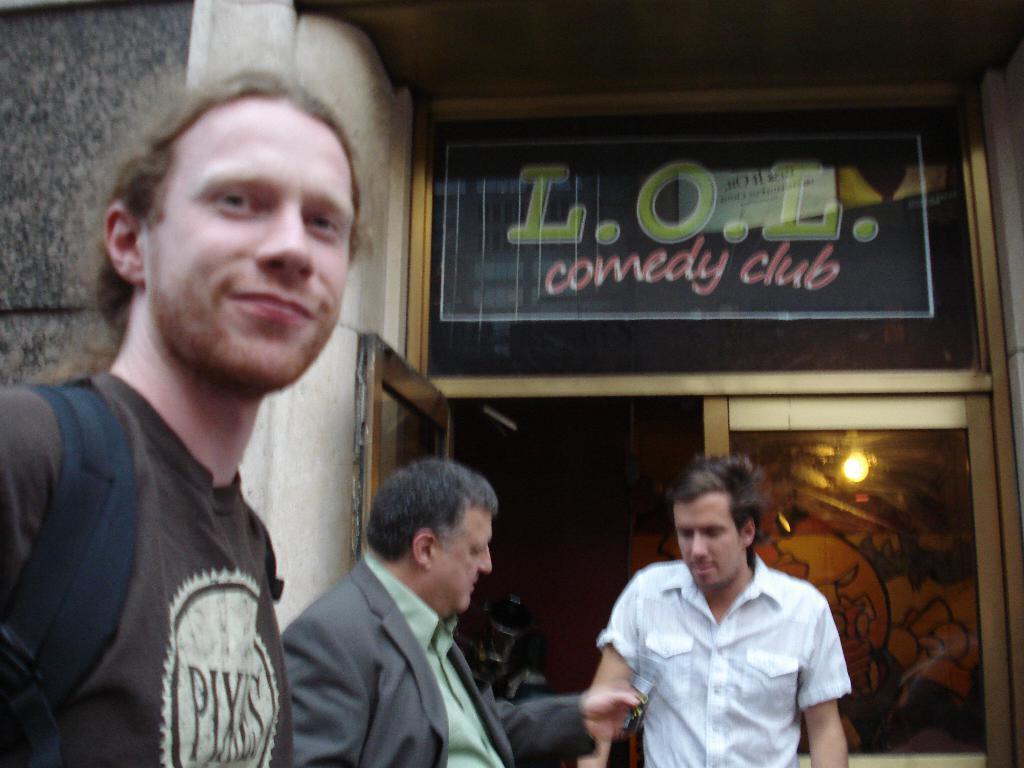In one or two sentences, can you explain what this image depicts? In this picture on the left side, we can also see man wearing a backpack. In the middle, we can also see two men. In the background, we can see a glass door and a wall. 